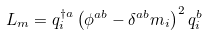Convert formula to latex. <formula><loc_0><loc_0><loc_500><loc_500>L _ { m } = q _ { i } ^ { \dagger a } \left ( \phi ^ { a b } - \delta ^ { a b } m _ { i } \right ) ^ { 2 } q ^ { b } _ { i }</formula> 